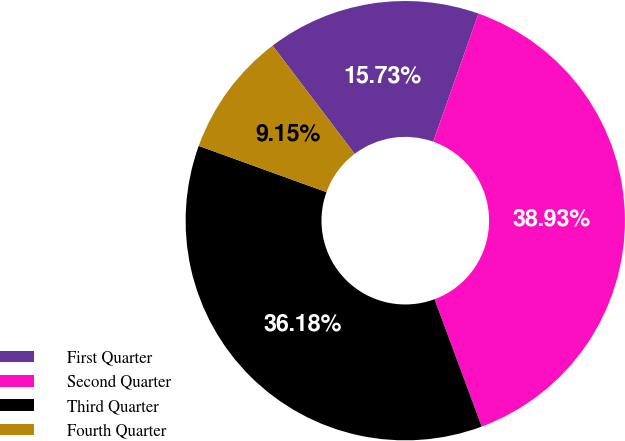Convert chart to OTSL. <chart><loc_0><loc_0><loc_500><loc_500><pie_chart><fcel>First Quarter<fcel>Second Quarter<fcel>Third Quarter<fcel>Fourth Quarter<nl><fcel>15.73%<fcel>38.93%<fcel>36.18%<fcel>9.15%<nl></chart> 